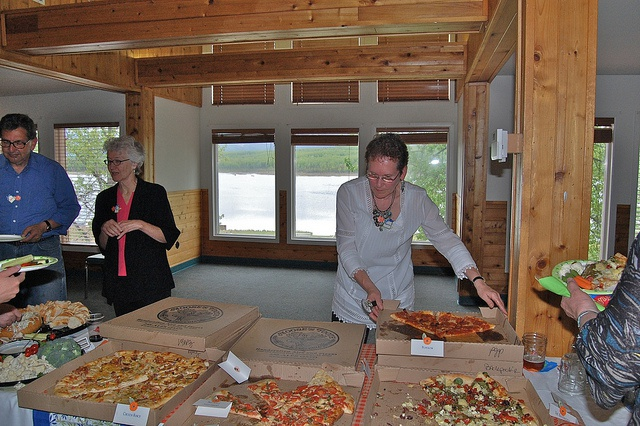Describe the objects in this image and their specific colors. I can see people in maroon and gray tones, people in maroon, black, and gray tones, people in maroon, navy, black, darkblue, and gray tones, people in maroon, black, gray, and darkgray tones, and pizza in maroon, olive, gray, and tan tones in this image. 